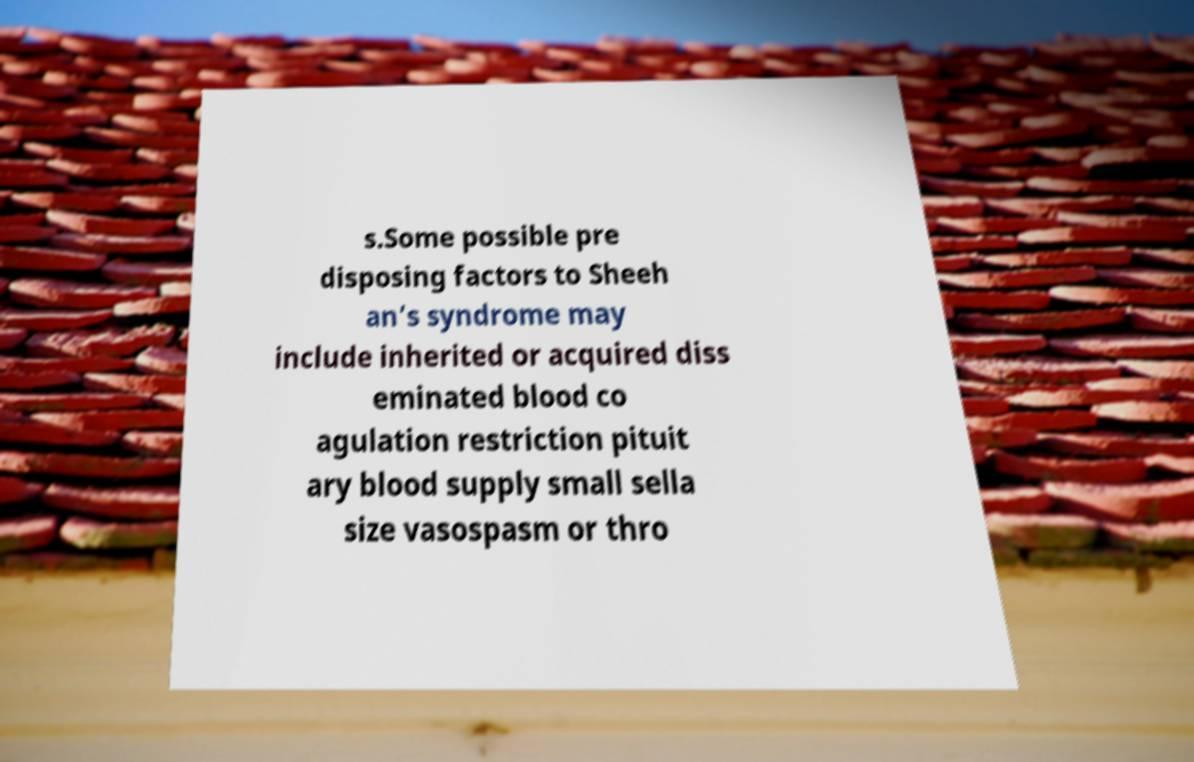Can you read and provide the text displayed in the image?This photo seems to have some interesting text. Can you extract and type it out for me? s.Some possible pre disposing factors to Sheeh an’s syndrome may include inherited or acquired diss eminated blood co agulation restriction pituit ary blood supply small sella size vasospasm or thro 